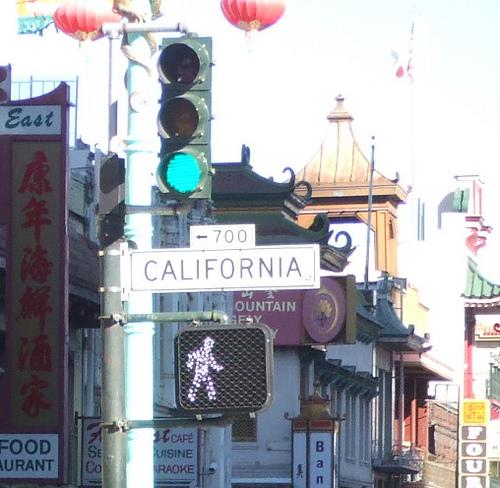What state is shown?
Concise answer only. California. What initial and numbers are under the stop light?
Be succinct. 700 california. What's that business on the other side of the street?
Answer briefly. Restaurant. Can you cross the street?
Quick response, please. Yes. What does the signal indicate should happen?
Concise answer only. Walk. What color is the light?
Write a very short answer. Green. 